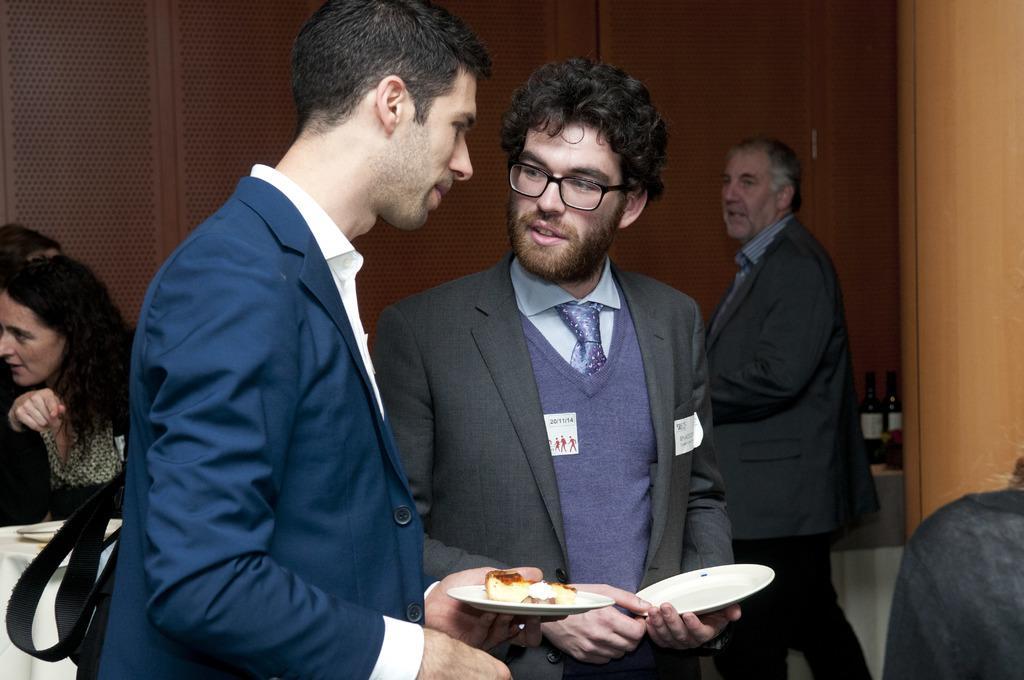Could you give a brief overview of what you see in this image? The man in white shirt and blue blazer is holding a plate containing food in his hands. Beside him, we see a man in grey blazer is holding an empty plate. I think both of them are talking. Behind them, we see a man in black blazer is standing. On the left side, we see a woman in black dress is sitting on the chair. In front of her, we see a table on which plate is placed. In the background, we see two glass bottles and a wall. 